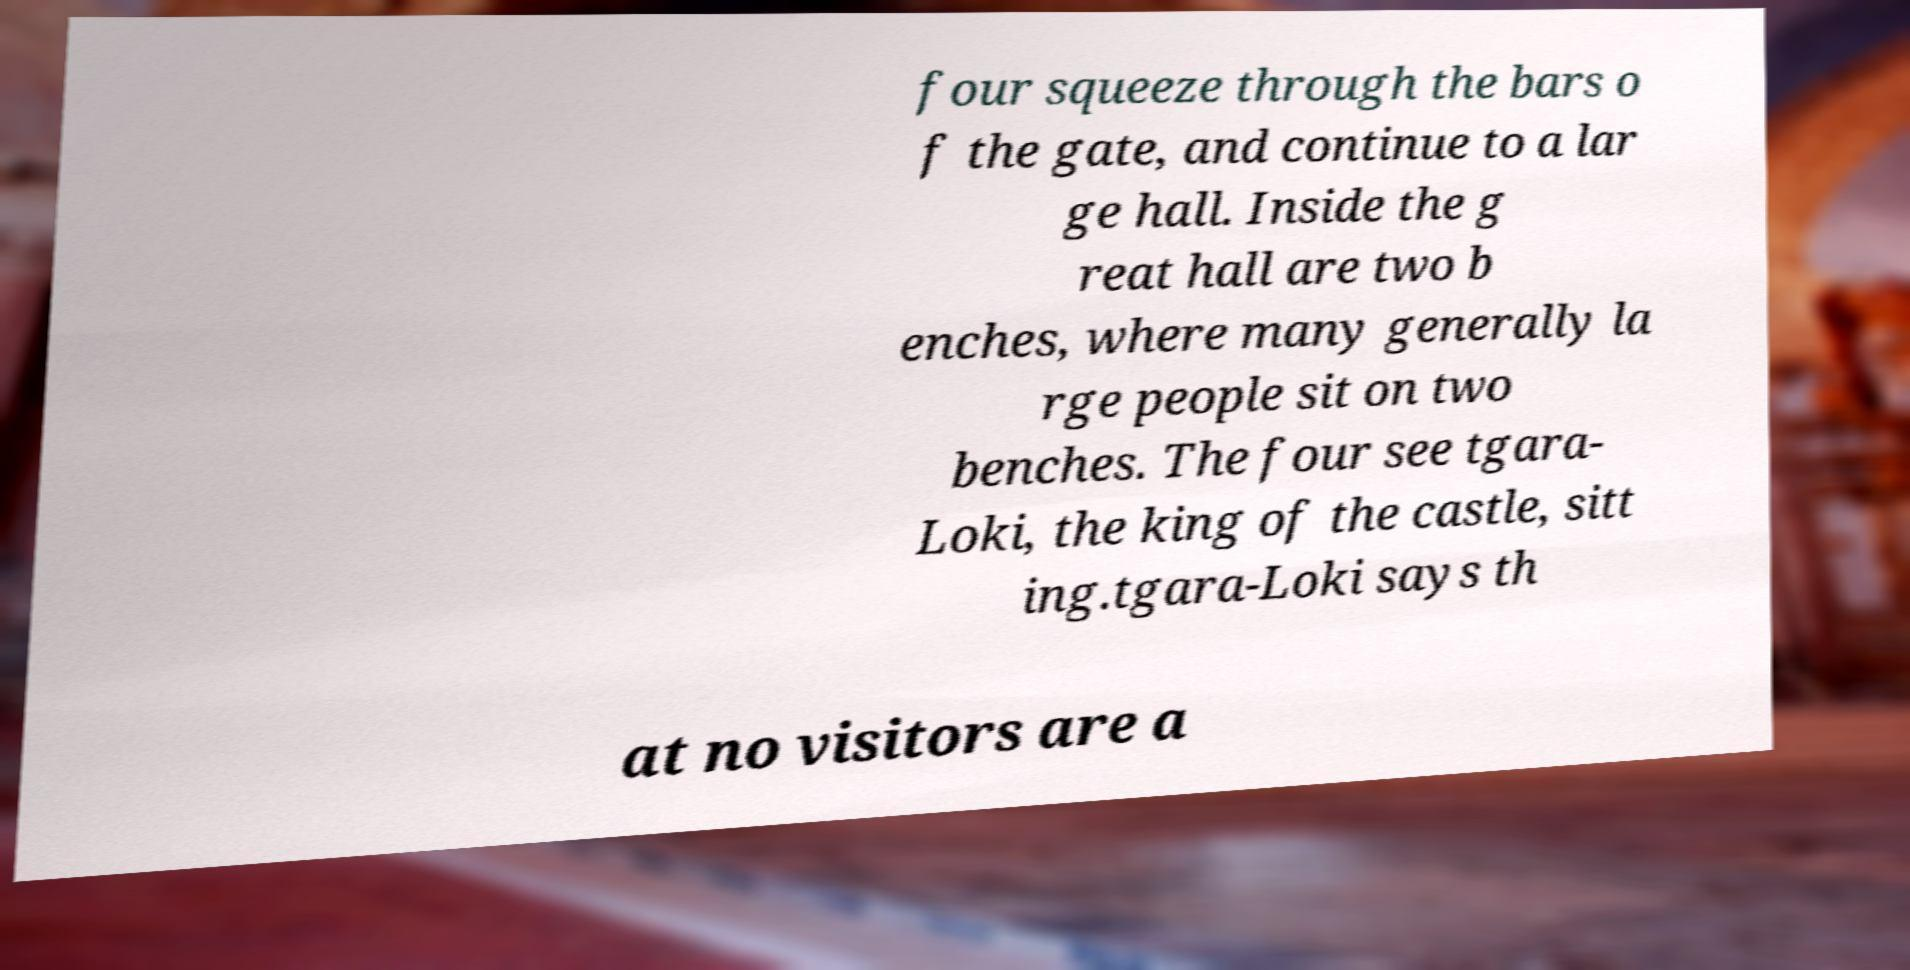Could you extract and type out the text from this image? four squeeze through the bars o f the gate, and continue to a lar ge hall. Inside the g reat hall are two b enches, where many generally la rge people sit on two benches. The four see tgara- Loki, the king of the castle, sitt ing.tgara-Loki says th at no visitors are a 